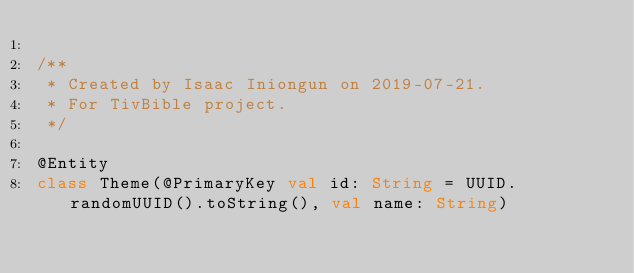Convert code to text. <code><loc_0><loc_0><loc_500><loc_500><_Kotlin_>
/**
 * Created by Isaac Iniongun on 2019-07-21.
 * For TivBible project.
 */

@Entity
class Theme(@PrimaryKey val id: String = UUID.randomUUID().toString(), val name: String)</code> 